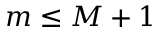<formula> <loc_0><loc_0><loc_500><loc_500>m \leq M + 1</formula> 